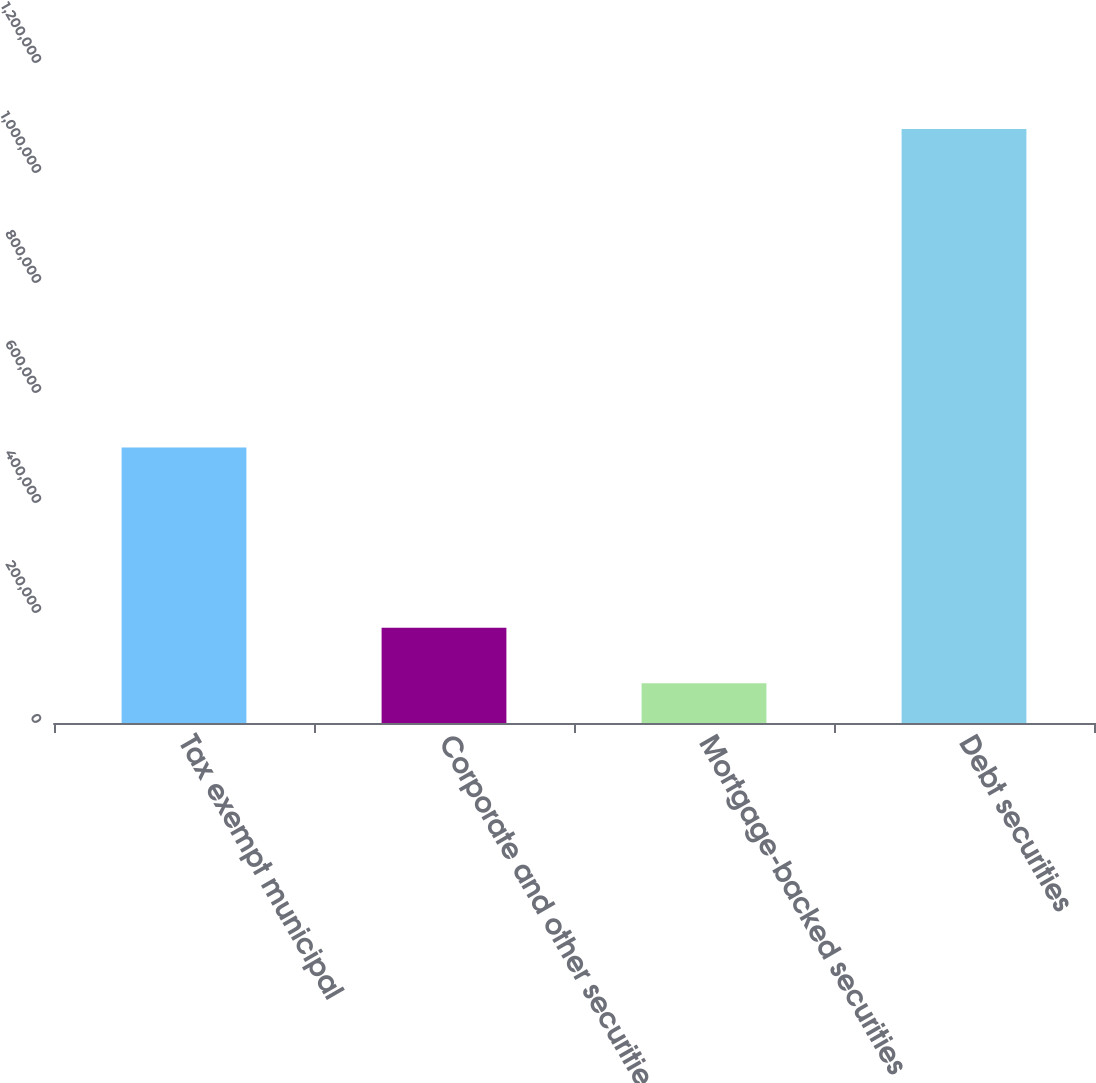<chart> <loc_0><loc_0><loc_500><loc_500><bar_chart><fcel>Tax exempt municipal<fcel>Corporate and other securities<fcel>Mortgage-backed securities<fcel>Debt securities<nl><fcel>501129<fcel>173208<fcel>72449<fcel>1.08004e+06<nl></chart> 